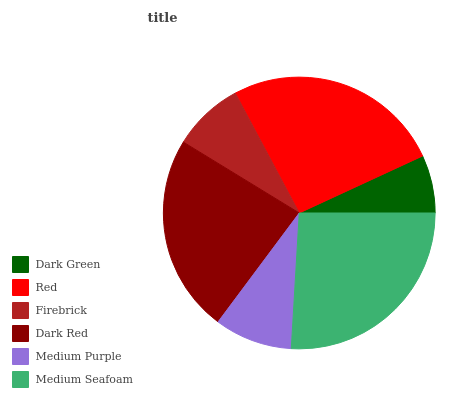Is Dark Green the minimum?
Answer yes or no. Yes. Is Medium Seafoam the maximum?
Answer yes or no. Yes. Is Red the minimum?
Answer yes or no. No. Is Red the maximum?
Answer yes or no. No. Is Red greater than Dark Green?
Answer yes or no. Yes. Is Dark Green less than Red?
Answer yes or no. Yes. Is Dark Green greater than Red?
Answer yes or no. No. Is Red less than Dark Green?
Answer yes or no. No. Is Dark Red the high median?
Answer yes or no. Yes. Is Medium Purple the low median?
Answer yes or no. Yes. Is Firebrick the high median?
Answer yes or no. No. Is Medium Seafoam the low median?
Answer yes or no. No. 